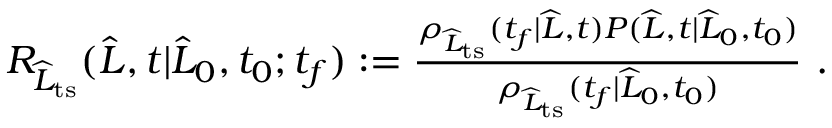Convert formula to latex. <formula><loc_0><loc_0><loc_500><loc_500>\begin{array} { r } { R _ { \widehat { L } _ { t s } } ( \widehat { L } , t | \widehat { L } _ { 0 } , t _ { 0 } ; t _ { f } ) \colon = \frac { \rho _ { \widehat { L } _ { t s } } ( t _ { f } | \widehat { L } , t ) P ( \widehat { L } , t | \widehat { L } _ { 0 } , t _ { 0 } ) } { \rho _ { \widehat { L } _ { t s } } ( t _ { f } | \widehat { L } _ { 0 } , t _ { 0 } ) } \ . } \end{array}</formula> 